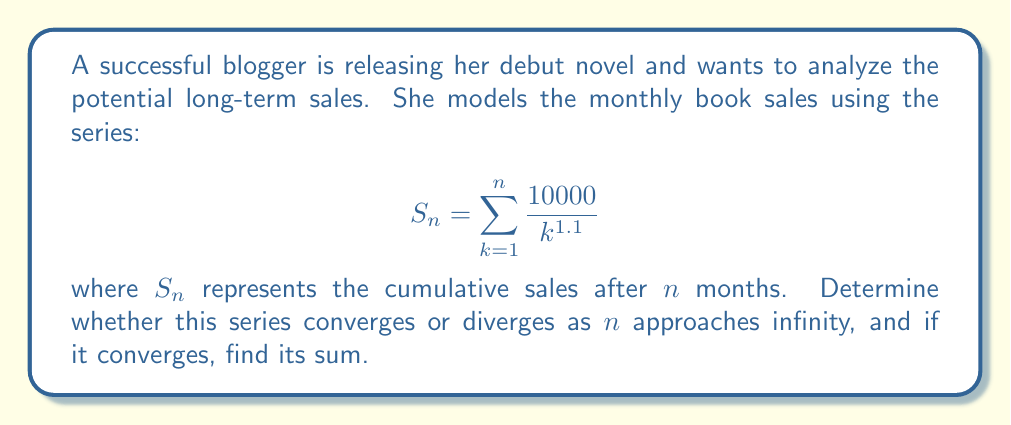Can you solve this math problem? To analyze the convergence of this series, we can use the p-series test:

1) The general form of a p-series is $\sum_{k=1}^{\infty} \frac{1}{k^p}$

2) Our series can be rewritten as:

   $$S_{\infty} = 10000 \sum_{k=1}^{\infty} \frac{1}{k^{1.1}}$$

3) For a p-series:
   - If $p > 1$, the series converges
   - If $p \leq 1$, the series diverges

4) In our case, $p = 1.1$, which is greater than 1

5) Therefore, the series converges

To find the sum, we can use the fact that for $p > 1$:

$$\sum_{k=1}^{\infty} \frac{1}{k^p} = \zeta(p)$$

where $\zeta(p)$ is the Riemann zeta function.

6) In our case:

   $$S_{\infty} = 10000 \cdot \zeta(1.1)$$

7) The value of $\zeta(1.1)$ can be approximated numerically:

   $\zeta(1.1) \approx 10.5844$

8) Therefore:

   $$S_{\infty} \approx 10000 \cdot 10.5844 = 105,844$$
Answer: The series converges, and its sum is approximately 105,844 books. 